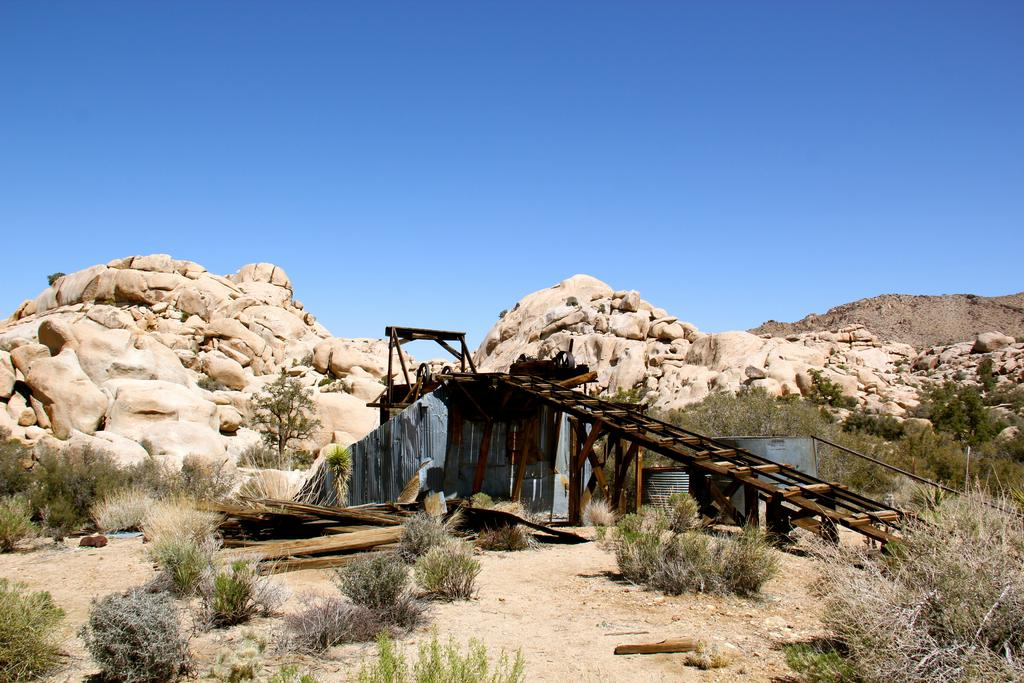What type of structure is present in the image? There is a wooden bridge in the image. What is the environment like around the wooden bridge? The wooden bridge is surrounded by plants. What can be seen in the distance behind the wooden bridge? There are rock mountains visible in the background of the image. What type of fruit is hanging from the wooden bridge in the image? There is no fruit hanging from the wooden bridge in the image. 